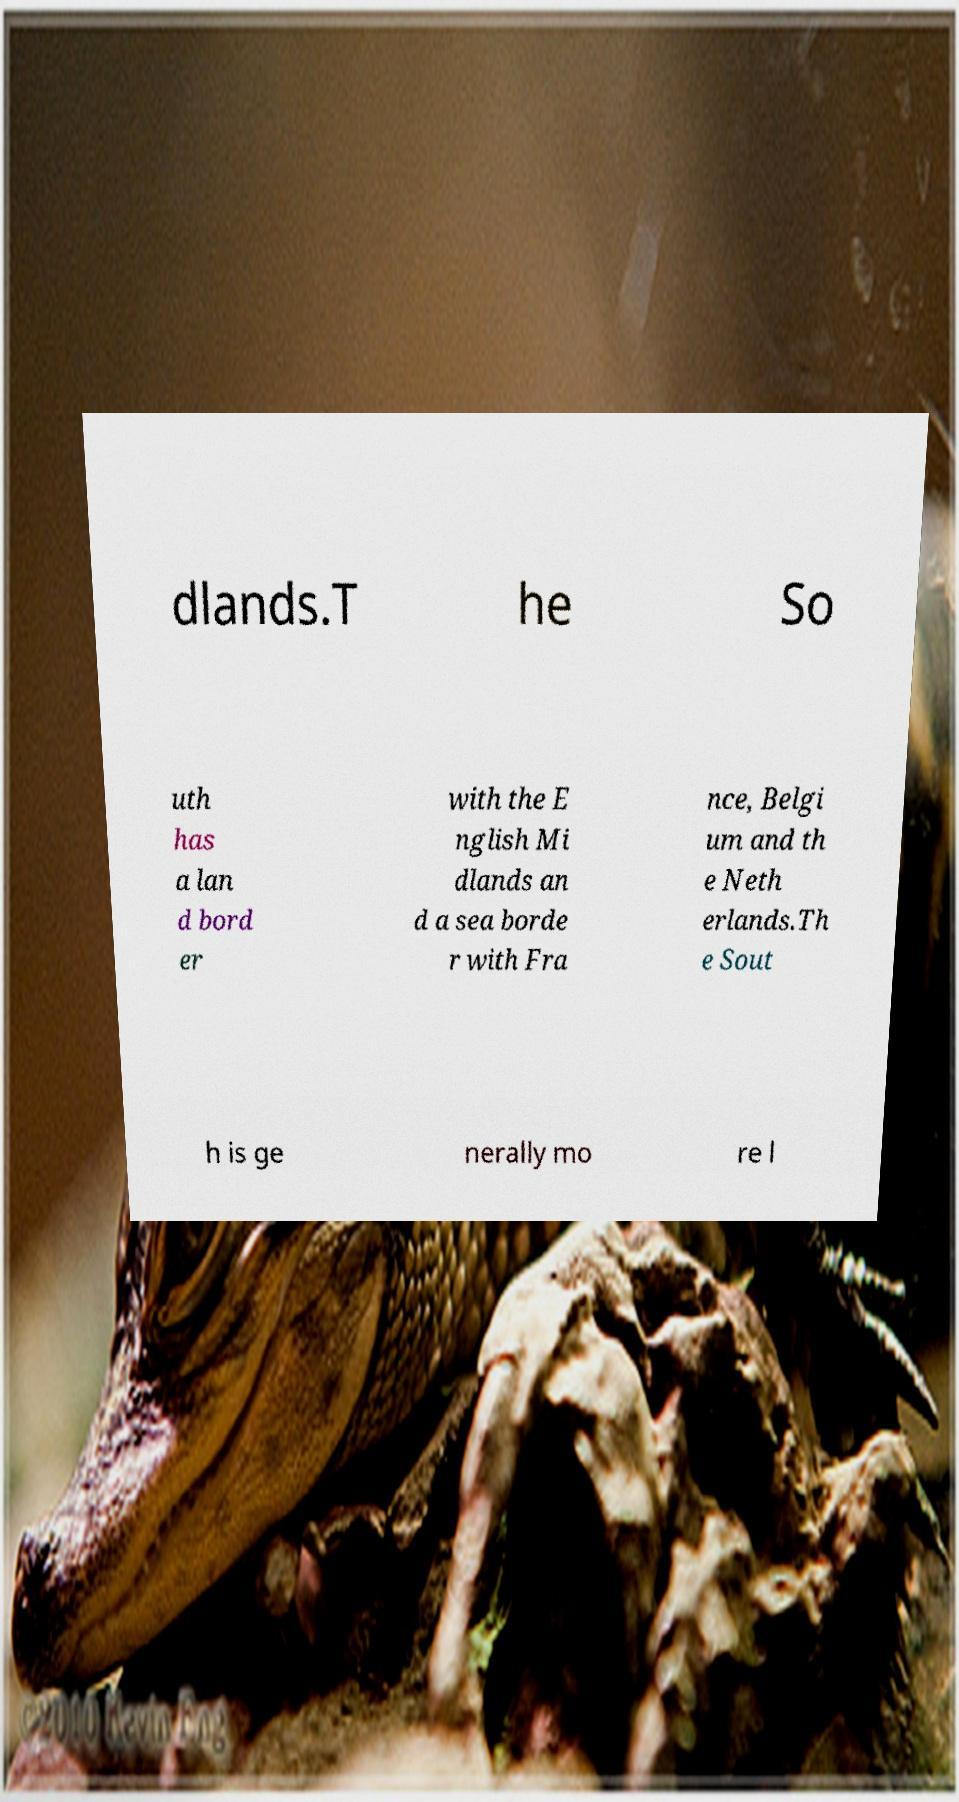Can you accurately transcribe the text from the provided image for me? dlands.T he So uth has a lan d bord er with the E nglish Mi dlands an d a sea borde r with Fra nce, Belgi um and th e Neth erlands.Th e Sout h is ge nerally mo re l 